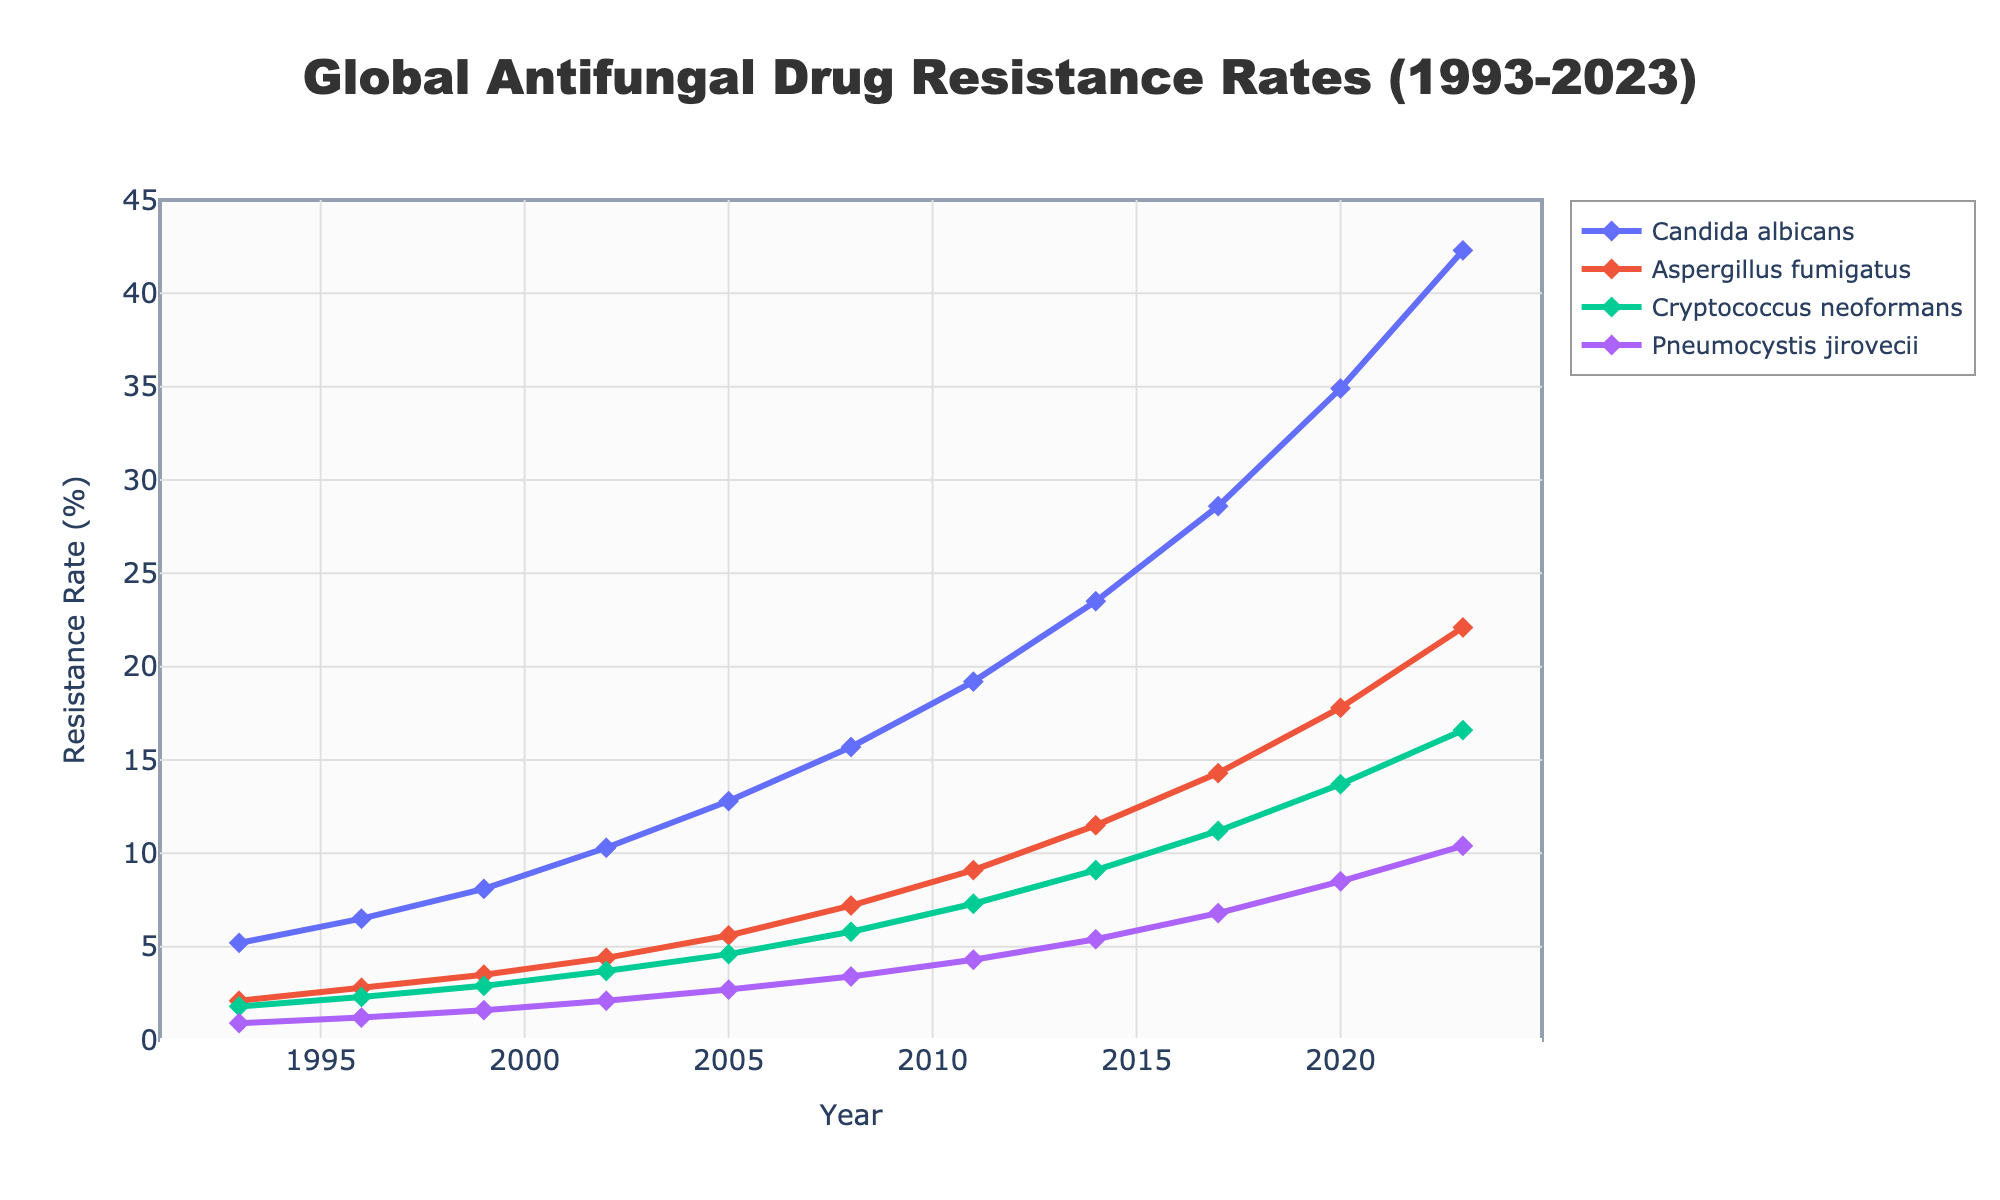What is the trend in antifungal drug resistance rates for Candida albicans from 1993 to 2023? To determine the trend in Candida albicans' resistance rates, observe the plotted line for this fungus from 1993 to 2023. The line consistently rises, starting at 5.2% in 1993 and reaching 42.3% in 2023.
Answer: Increasing In which year did Aspergillus fumigatus's resistance rate surpass 10% for the first time? Examine the line representing Aspergillus fumigatus; identify the year before the resistance rate crosses 10%. It happens between 2011 (9.1%) and 2014 (11.5%). Therefore, the year is 2014.
Answer: 2014 By how much did the resistance rate of Pneumocystis jirovecii increase from 1993 to 2023? Calculate the difference between the resistance rate in 2023 and 1993 for Pneumocystis jirovecii. The rate in 1993 was 0.9%, and in 2023 it is 10.4%. Subtract 0.9% from 10.4%: 10.4% - 0.9% = 9.5%.
Answer: 9.5% Compare the resistance rates of Candida albicans and Cryptococcus neoformans in 2008. Which one was higher, and by how much? Look at the data for 2008: Candida albicans has a resistance rate of 15.7%, while Cryptococcus neoformans has 5.8%. Subtract 5.8% from 15.7%: 15.7% - 5.8% = 9.9%. Therefore, Candida albicans had a higher resistance rate.
Answer: Candida albicans, 9.9% What was the average resistance rate of Aspergillus fumigatus from 1993 to 2023? To find the average resistance rate, sum the rates for Aspergillus fumigatus over the years given and divide by the number of years recorded (11 years). (2.1 + 2.8 + 3.5 + 4.4 + 5.6 + 7.2 + 9.1 + 11.5 + 14.3 + 17.8 + 22.1) / 11 = 100.4 / 11 = 9.13 (rounded to 2 decimal places).
Answer: 9.13% What is the difference in the slopes of resistance rate lines between Cryptococcus neoformans and Pneumocystis jirovecii from 1993 to 2023? Calculate the overall change for each pathogen and divide by the number of years: (For Cryptococcus neoformans: 16.6% - 1.8% = 14.8% over 30 years, slope = 14.8/30 = 0.493%. For Pneumocystis jirovecii: 10.4% - 0.9% = 9.5% over 30 years, slope = 9.5/30 = 0.317%). Difference = 0.493% - 0.317% = 0.176%.
Answer: 0.176% In which year did the rate of resistance for Candida albicans become more than double the rate for Aspergillus fumigatus? Look for the year when Candida albicans' resistance rate is more than twice that of Aspergillus fumigatus. This happens around 1999 (8.1% vs. a little more than 3.5%, near but not yet). By 2002, Candida albicans (10.3%) is well over double Aspergillus fumigatus (4.4%).
Answer: 2002 